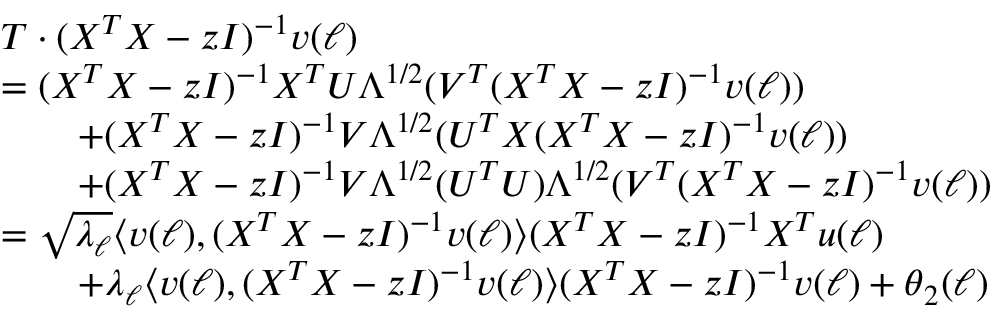<formula> <loc_0><loc_0><loc_500><loc_500>\begin{array} { r l } & { T \cdot ( X ^ { T } X - z I ) ^ { - 1 } { \boldsymbol v } ( \ell ) } \\ & { = ( X ^ { T } X - z I ) ^ { - 1 } X ^ { T } { \boldsymbol U } \Lambda ^ { 1 / 2 } ( { \boldsymbol V } ^ { T } ( X ^ { T } X - z I ) ^ { - 1 } { \boldsymbol v } ( \ell ) ) } \\ & { \quad + ( X ^ { T } X - z I ) ^ { - 1 } { \boldsymbol V } \Lambda ^ { 1 / 2 } ( { \boldsymbol U } ^ { T } X ( X ^ { T } X - z I ) ^ { - 1 } { \boldsymbol v } ( \ell ) ) } \\ & { \quad + ( X ^ { T } X - z I ) ^ { - 1 } { \boldsymbol V } \Lambda ^ { 1 / 2 } ( { \boldsymbol U } ^ { T } { \boldsymbol U } ) \Lambda ^ { 1 / 2 } ( { \boldsymbol V } ^ { T } ( X ^ { T } X - z I ) ^ { - 1 } { \boldsymbol v } ( \ell ) ) } \\ & { = \sqrt { \lambda _ { \ell } } \langle { \boldsymbol v } ( \ell ) , ( X ^ { T } X - z I ) ^ { - 1 } { \boldsymbol v } ( \ell ) \rangle ( X ^ { T } X - z I ) ^ { - 1 } X ^ { T } { \boldsymbol u } ( \ell ) } \\ & { \quad + \lambda _ { \ell } \langle { \boldsymbol v } ( \ell ) , ( X ^ { T } X - z I ) ^ { - 1 } { \boldsymbol v } ( \ell ) \rangle ( X ^ { T } X - z I ) ^ { - 1 } { \boldsymbol v } ( \ell ) + { \boldsymbol \theta } _ { 2 } ( \ell ) } \end{array}</formula> 